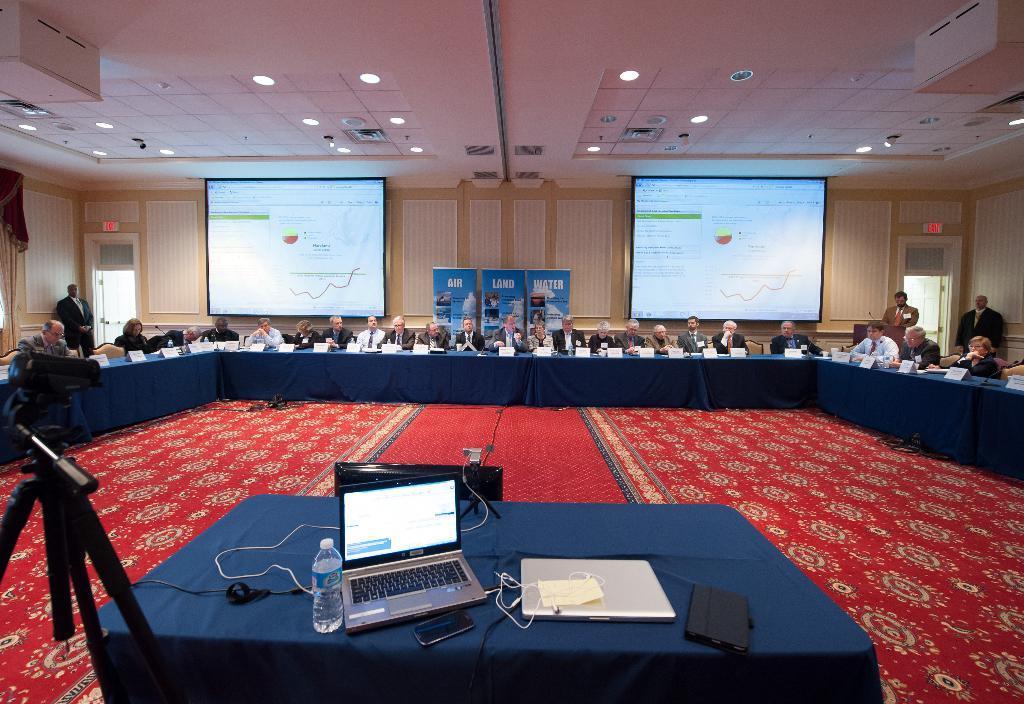In one or two sentences, can you explain what this image depicts? This image is taken in a conference room, in the foreground of the image there is a table with a bottle, laptop, phone, tab and other objects are on top of it, beside that there is a camera stand, in front of the table there are so many people sitting on the chairs, in front of them there is a table with name plates and other objects on it. On the left and right side of the image there are a few people standing. In the background there are two screens hanging on the wall and there are banners with some text on it. On the left and right side of the image there are doors. At the top of the image there is a railing with lights. 